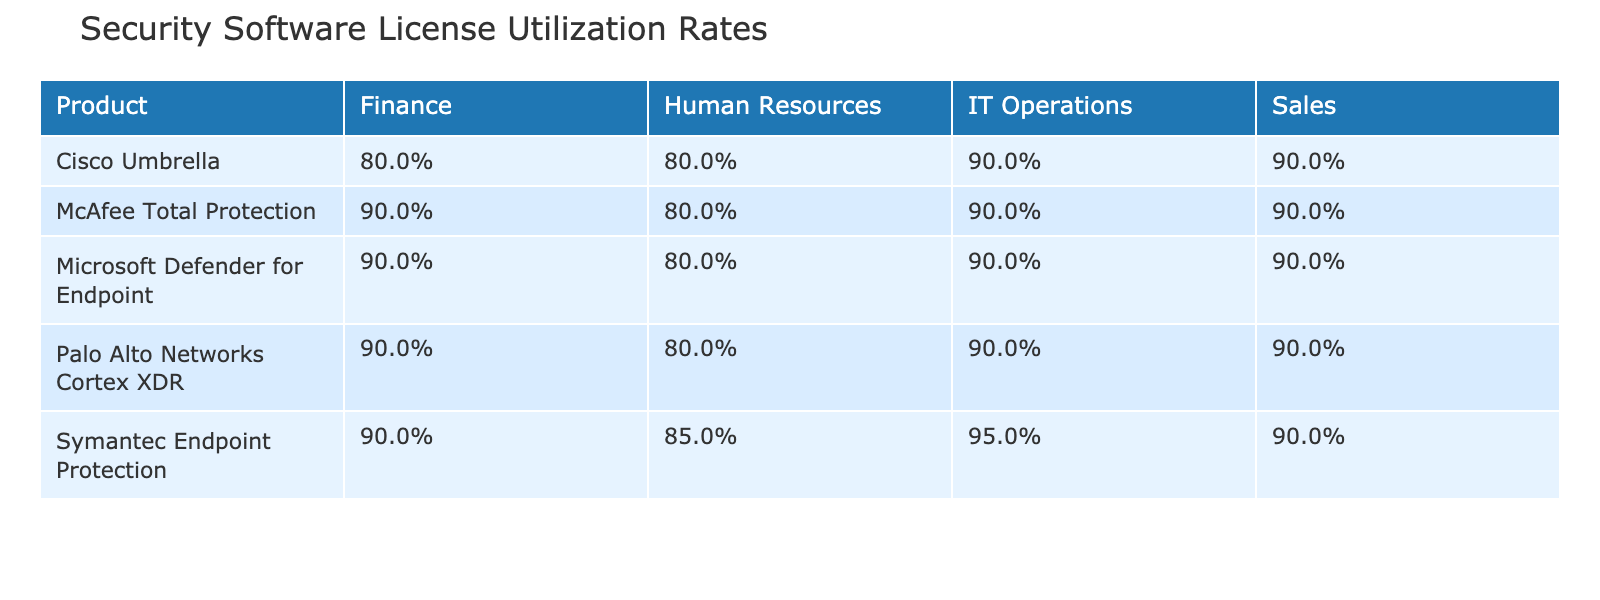What is the utilization rate of Symantec Endpoint Protection in the Human Resources unit? The table shows that for Symantec Endpoint Protection in the Human Resources unit, the utilization rate is listed directly as 85%.
Answer: 85% Which product has the highest utilization rate in Finance? Looking across the Finance column, Symantec Endpoint Protection, McAfee Total Protection, and Palo Alto Networks Cortex XDR each have a utilization rate of 90%, whereas Cisco Umbrella is at 80%. They are all equal, so no single product has the highest rate.
Answer: No single highest What is the average utilization rate of Cisco Umbrella across all business units? The rates for Cisco Umbrella per unit are 90%, 80%, 80%, and 90%. Summing these gives 90 + 80 + 80 + 90 = 340. There are 4 entries, so the average is 340 / 4 = 85%.
Answer: 85% Does the Sales unit have a utilization rate of 90% for Microsoft Defender for Endpoint? The table indicates that the utilization rate for Microsoft Defender for Endpoint in the Sales unit is 90%. Therefore, the statement is true.
Answer: Yes Which business unit has the lowest utilization rate for McAfee Total Protection? By evaluating the utilization rates listed for McAfee Total Protection, the rates are 90%, 90%, 80%, and 90% across IT Operations, Finance, Human Resources, and Sales respectively. The lowest among these is 80% in Human Resources.
Answer: Human Resources What is the total number of utilized licenses for Palo Alto Networks Cortex XDR across all business units? The utilized licenses for Palo Alto Networks Cortex XDR in the various business units are 405, 162, 72, and 243. Summing these gives 405 + 162 + 72 + 243 = 882 utilized licenses.
Answer: 882 Which product has the lowest total licenses available overall? Summing up the total licenses for all products shows the following: Symantec Endpoint Protection: 1,100, McAfee Total Protection: 875, Cisco Umbrella: 1,320, Palo Alto Networks Cortex XDR: 1,020, and Microsoft Defender for Endpoint: 1,210. The product with the lowest total licenses is McAfee Total Protection with 875.
Answer: McAfee Total Protection What is the difference in utilization rates between the IT Operations and Sales units for Microsoft Defender for Endpoint? The utilization rate for IT Operations is 90%, and for Sales is also 90%. The difference is 90 - 90 = 0%.
Answer: 0% 